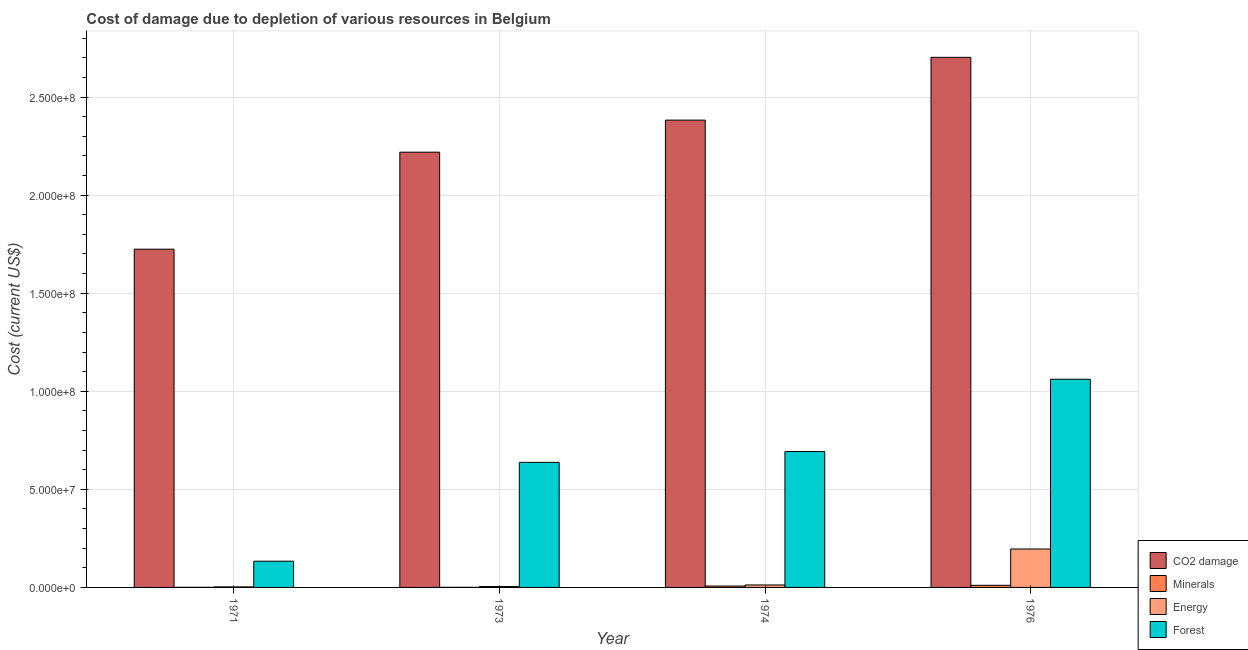How many different coloured bars are there?
Make the answer very short. 4. How many bars are there on the 4th tick from the left?
Provide a succinct answer. 4. How many bars are there on the 1st tick from the right?
Provide a short and direct response. 4. What is the label of the 4th group of bars from the left?
Your response must be concise. 1976. What is the cost of damage due to depletion of energy in 1971?
Give a very brief answer. 2.79e+05. Across all years, what is the maximum cost of damage due to depletion of energy?
Ensure brevity in your answer.  1.96e+07. Across all years, what is the minimum cost of damage due to depletion of energy?
Offer a terse response. 2.79e+05. In which year was the cost of damage due to depletion of forests maximum?
Offer a very short reply. 1976. In which year was the cost of damage due to depletion of energy minimum?
Provide a succinct answer. 1971. What is the total cost of damage due to depletion of coal in the graph?
Keep it short and to the point. 9.03e+08. What is the difference between the cost of damage due to depletion of forests in 1971 and that in 1976?
Provide a succinct answer. -9.28e+07. What is the difference between the cost of damage due to depletion of energy in 1976 and the cost of damage due to depletion of forests in 1973?
Your answer should be very brief. 1.91e+07. What is the average cost of damage due to depletion of forests per year?
Provide a short and direct response. 6.31e+07. In the year 1974, what is the difference between the cost of damage due to depletion of energy and cost of damage due to depletion of coal?
Your answer should be compact. 0. What is the ratio of the cost of damage due to depletion of coal in 1971 to that in 1973?
Your answer should be very brief. 0.78. Is the cost of damage due to depletion of minerals in 1973 less than that in 1976?
Make the answer very short. Yes. Is the difference between the cost of damage due to depletion of minerals in 1973 and 1974 greater than the difference between the cost of damage due to depletion of forests in 1973 and 1974?
Keep it short and to the point. No. What is the difference between the highest and the second highest cost of damage due to depletion of energy?
Keep it short and to the point. 1.83e+07. What is the difference between the highest and the lowest cost of damage due to depletion of coal?
Give a very brief answer. 9.78e+07. In how many years, is the cost of damage due to depletion of forests greater than the average cost of damage due to depletion of forests taken over all years?
Offer a terse response. 3. What does the 2nd bar from the left in 1974 represents?
Your answer should be very brief. Minerals. What does the 2nd bar from the right in 1973 represents?
Give a very brief answer. Energy. How many bars are there?
Your answer should be very brief. 16. Are the values on the major ticks of Y-axis written in scientific E-notation?
Offer a terse response. Yes. Where does the legend appear in the graph?
Provide a succinct answer. Bottom right. How are the legend labels stacked?
Provide a short and direct response. Vertical. What is the title of the graph?
Give a very brief answer. Cost of damage due to depletion of various resources in Belgium . What is the label or title of the Y-axis?
Your response must be concise. Cost (current US$). What is the Cost (current US$) of CO2 damage in 1971?
Make the answer very short. 1.72e+08. What is the Cost (current US$) of Minerals in 1971?
Give a very brief answer. 6.47e+04. What is the Cost (current US$) of Energy in 1971?
Provide a short and direct response. 2.79e+05. What is the Cost (current US$) of Forest in 1971?
Provide a short and direct response. 1.34e+07. What is the Cost (current US$) in CO2 damage in 1973?
Ensure brevity in your answer.  2.22e+08. What is the Cost (current US$) of Minerals in 1973?
Your response must be concise. 4.70e+04. What is the Cost (current US$) of Energy in 1973?
Offer a very short reply. 4.66e+05. What is the Cost (current US$) of Forest in 1973?
Make the answer very short. 6.38e+07. What is the Cost (current US$) in CO2 damage in 1974?
Offer a very short reply. 2.38e+08. What is the Cost (current US$) in Minerals in 1974?
Provide a short and direct response. 7.12e+05. What is the Cost (current US$) of Energy in 1974?
Offer a terse response. 1.25e+06. What is the Cost (current US$) of Forest in 1974?
Make the answer very short. 6.93e+07. What is the Cost (current US$) of CO2 damage in 1976?
Your response must be concise. 2.70e+08. What is the Cost (current US$) in Minerals in 1976?
Keep it short and to the point. 1.08e+06. What is the Cost (current US$) of Energy in 1976?
Your answer should be compact. 1.96e+07. What is the Cost (current US$) of Forest in 1976?
Your response must be concise. 1.06e+08. Across all years, what is the maximum Cost (current US$) of CO2 damage?
Your answer should be compact. 2.70e+08. Across all years, what is the maximum Cost (current US$) in Minerals?
Your answer should be compact. 1.08e+06. Across all years, what is the maximum Cost (current US$) of Energy?
Offer a very short reply. 1.96e+07. Across all years, what is the maximum Cost (current US$) in Forest?
Make the answer very short. 1.06e+08. Across all years, what is the minimum Cost (current US$) in CO2 damage?
Provide a succinct answer. 1.72e+08. Across all years, what is the minimum Cost (current US$) in Minerals?
Offer a terse response. 4.70e+04. Across all years, what is the minimum Cost (current US$) in Energy?
Offer a terse response. 2.79e+05. Across all years, what is the minimum Cost (current US$) of Forest?
Ensure brevity in your answer.  1.34e+07. What is the total Cost (current US$) in CO2 damage in the graph?
Your response must be concise. 9.03e+08. What is the total Cost (current US$) of Minerals in the graph?
Your response must be concise. 1.90e+06. What is the total Cost (current US$) of Energy in the graph?
Offer a very short reply. 2.16e+07. What is the total Cost (current US$) in Forest in the graph?
Your answer should be very brief. 2.53e+08. What is the difference between the Cost (current US$) in CO2 damage in 1971 and that in 1973?
Give a very brief answer. -4.95e+07. What is the difference between the Cost (current US$) in Minerals in 1971 and that in 1973?
Your answer should be compact. 1.76e+04. What is the difference between the Cost (current US$) of Energy in 1971 and that in 1973?
Provide a succinct answer. -1.87e+05. What is the difference between the Cost (current US$) in Forest in 1971 and that in 1973?
Offer a very short reply. -5.04e+07. What is the difference between the Cost (current US$) in CO2 damage in 1971 and that in 1974?
Make the answer very short. -6.58e+07. What is the difference between the Cost (current US$) in Minerals in 1971 and that in 1974?
Provide a succinct answer. -6.47e+05. What is the difference between the Cost (current US$) in Energy in 1971 and that in 1974?
Offer a terse response. -9.75e+05. What is the difference between the Cost (current US$) in Forest in 1971 and that in 1974?
Your answer should be very brief. -5.59e+07. What is the difference between the Cost (current US$) of CO2 damage in 1971 and that in 1976?
Provide a short and direct response. -9.78e+07. What is the difference between the Cost (current US$) in Minerals in 1971 and that in 1976?
Offer a very short reply. -1.01e+06. What is the difference between the Cost (current US$) in Energy in 1971 and that in 1976?
Offer a very short reply. -1.93e+07. What is the difference between the Cost (current US$) in Forest in 1971 and that in 1976?
Ensure brevity in your answer.  -9.28e+07. What is the difference between the Cost (current US$) of CO2 damage in 1973 and that in 1974?
Your answer should be compact. -1.63e+07. What is the difference between the Cost (current US$) of Minerals in 1973 and that in 1974?
Your answer should be very brief. -6.65e+05. What is the difference between the Cost (current US$) in Energy in 1973 and that in 1974?
Give a very brief answer. -7.87e+05. What is the difference between the Cost (current US$) in Forest in 1973 and that in 1974?
Offer a very short reply. -5.53e+06. What is the difference between the Cost (current US$) in CO2 damage in 1973 and that in 1976?
Your answer should be compact. -4.84e+07. What is the difference between the Cost (current US$) in Minerals in 1973 and that in 1976?
Make the answer very short. -1.03e+06. What is the difference between the Cost (current US$) in Energy in 1973 and that in 1976?
Your response must be concise. -1.91e+07. What is the difference between the Cost (current US$) in Forest in 1973 and that in 1976?
Your answer should be very brief. -4.24e+07. What is the difference between the Cost (current US$) in CO2 damage in 1974 and that in 1976?
Make the answer very short. -3.20e+07. What is the difference between the Cost (current US$) of Minerals in 1974 and that in 1976?
Make the answer very short. -3.66e+05. What is the difference between the Cost (current US$) of Energy in 1974 and that in 1976?
Make the answer very short. -1.83e+07. What is the difference between the Cost (current US$) in Forest in 1974 and that in 1976?
Make the answer very short. -3.69e+07. What is the difference between the Cost (current US$) of CO2 damage in 1971 and the Cost (current US$) of Minerals in 1973?
Give a very brief answer. 1.72e+08. What is the difference between the Cost (current US$) in CO2 damage in 1971 and the Cost (current US$) in Energy in 1973?
Offer a terse response. 1.72e+08. What is the difference between the Cost (current US$) in CO2 damage in 1971 and the Cost (current US$) in Forest in 1973?
Your answer should be very brief. 1.09e+08. What is the difference between the Cost (current US$) of Minerals in 1971 and the Cost (current US$) of Energy in 1973?
Ensure brevity in your answer.  -4.01e+05. What is the difference between the Cost (current US$) in Minerals in 1971 and the Cost (current US$) in Forest in 1973?
Your response must be concise. -6.37e+07. What is the difference between the Cost (current US$) of Energy in 1971 and the Cost (current US$) of Forest in 1973?
Give a very brief answer. -6.35e+07. What is the difference between the Cost (current US$) in CO2 damage in 1971 and the Cost (current US$) in Minerals in 1974?
Offer a terse response. 1.72e+08. What is the difference between the Cost (current US$) of CO2 damage in 1971 and the Cost (current US$) of Energy in 1974?
Your response must be concise. 1.71e+08. What is the difference between the Cost (current US$) of CO2 damage in 1971 and the Cost (current US$) of Forest in 1974?
Provide a short and direct response. 1.03e+08. What is the difference between the Cost (current US$) in Minerals in 1971 and the Cost (current US$) in Energy in 1974?
Give a very brief answer. -1.19e+06. What is the difference between the Cost (current US$) in Minerals in 1971 and the Cost (current US$) in Forest in 1974?
Make the answer very short. -6.92e+07. What is the difference between the Cost (current US$) of Energy in 1971 and the Cost (current US$) of Forest in 1974?
Give a very brief answer. -6.90e+07. What is the difference between the Cost (current US$) of CO2 damage in 1971 and the Cost (current US$) of Minerals in 1976?
Your answer should be very brief. 1.71e+08. What is the difference between the Cost (current US$) in CO2 damage in 1971 and the Cost (current US$) in Energy in 1976?
Your answer should be very brief. 1.53e+08. What is the difference between the Cost (current US$) in CO2 damage in 1971 and the Cost (current US$) in Forest in 1976?
Ensure brevity in your answer.  6.63e+07. What is the difference between the Cost (current US$) of Minerals in 1971 and the Cost (current US$) of Energy in 1976?
Give a very brief answer. -1.95e+07. What is the difference between the Cost (current US$) of Minerals in 1971 and the Cost (current US$) of Forest in 1976?
Provide a succinct answer. -1.06e+08. What is the difference between the Cost (current US$) of Energy in 1971 and the Cost (current US$) of Forest in 1976?
Make the answer very short. -1.06e+08. What is the difference between the Cost (current US$) of CO2 damage in 1973 and the Cost (current US$) of Minerals in 1974?
Offer a very short reply. 2.21e+08. What is the difference between the Cost (current US$) of CO2 damage in 1973 and the Cost (current US$) of Energy in 1974?
Ensure brevity in your answer.  2.21e+08. What is the difference between the Cost (current US$) in CO2 damage in 1973 and the Cost (current US$) in Forest in 1974?
Offer a very short reply. 1.53e+08. What is the difference between the Cost (current US$) of Minerals in 1973 and the Cost (current US$) of Energy in 1974?
Make the answer very short. -1.21e+06. What is the difference between the Cost (current US$) in Minerals in 1973 and the Cost (current US$) in Forest in 1974?
Provide a short and direct response. -6.92e+07. What is the difference between the Cost (current US$) of Energy in 1973 and the Cost (current US$) of Forest in 1974?
Make the answer very short. -6.88e+07. What is the difference between the Cost (current US$) of CO2 damage in 1973 and the Cost (current US$) of Minerals in 1976?
Provide a short and direct response. 2.21e+08. What is the difference between the Cost (current US$) of CO2 damage in 1973 and the Cost (current US$) of Energy in 1976?
Make the answer very short. 2.02e+08. What is the difference between the Cost (current US$) of CO2 damage in 1973 and the Cost (current US$) of Forest in 1976?
Ensure brevity in your answer.  1.16e+08. What is the difference between the Cost (current US$) in Minerals in 1973 and the Cost (current US$) in Energy in 1976?
Provide a succinct answer. -1.95e+07. What is the difference between the Cost (current US$) in Minerals in 1973 and the Cost (current US$) in Forest in 1976?
Your response must be concise. -1.06e+08. What is the difference between the Cost (current US$) in Energy in 1973 and the Cost (current US$) in Forest in 1976?
Offer a very short reply. -1.06e+08. What is the difference between the Cost (current US$) of CO2 damage in 1974 and the Cost (current US$) of Minerals in 1976?
Offer a terse response. 2.37e+08. What is the difference between the Cost (current US$) of CO2 damage in 1974 and the Cost (current US$) of Energy in 1976?
Your answer should be very brief. 2.19e+08. What is the difference between the Cost (current US$) of CO2 damage in 1974 and the Cost (current US$) of Forest in 1976?
Your response must be concise. 1.32e+08. What is the difference between the Cost (current US$) in Minerals in 1974 and the Cost (current US$) in Energy in 1976?
Ensure brevity in your answer.  -1.89e+07. What is the difference between the Cost (current US$) of Minerals in 1974 and the Cost (current US$) of Forest in 1976?
Give a very brief answer. -1.05e+08. What is the difference between the Cost (current US$) in Energy in 1974 and the Cost (current US$) in Forest in 1976?
Provide a succinct answer. -1.05e+08. What is the average Cost (current US$) in CO2 damage per year?
Your answer should be compact. 2.26e+08. What is the average Cost (current US$) of Minerals per year?
Provide a short and direct response. 4.75e+05. What is the average Cost (current US$) of Energy per year?
Provide a succinct answer. 5.40e+06. What is the average Cost (current US$) of Forest per year?
Ensure brevity in your answer.  6.31e+07. In the year 1971, what is the difference between the Cost (current US$) in CO2 damage and Cost (current US$) in Minerals?
Offer a terse response. 1.72e+08. In the year 1971, what is the difference between the Cost (current US$) of CO2 damage and Cost (current US$) of Energy?
Offer a very short reply. 1.72e+08. In the year 1971, what is the difference between the Cost (current US$) of CO2 damage and Cost (current US$) of Forest?
Offer a terse response. 1.59e+08. In the year 1971, what is the difference between the Cost (current US$) of Minerals and Cost (current US$) of Energy?
Your answer should be compact. -2.14e+05. In the year 1971, what is the difference between the Cost (current US$) of Minerals and Cost (current US$) of Forest?
Keep it short and to the point. -1.33e+07. In the year 1971, what is the difference between the Cost (current US$) in Energy and Cost (current US$) in Forest?
Make the answer very short. -1.31e+07. In the year 1973, what is the difference between the Cost (current US$) in CO2 damage and Cost (current US$) in Minerals?
Your response must be concise. 2.22e+08. In the year 1973, what is the difference between the Cost (current US$) of CO2 damage and Cost (current US$) of Energy?
Make the answer very short. 2.21e+08. In the year 1973, what is the difference between the Cost (current US$) of CO2 damage and Cost (current US$) of Forest?
Ensure brevity in your answer.  1.58e+08. In the year 1973, what is the difference between the Cost (current US$) of Minerals and Cost (current US$) of Energy?
Keep it short and to the point. -4.19e+05. In the year 1973, what is the difference between the Cost (current US$) of Minerals and Cost (current US$) of Forest?
Your response must be concise. -6.37e+07. In the year 1973, what is the difference between the Cost (current US$) of Energy and Cost (current US$) of Forest?
Your response must be concise. -6.33e+07. In the year 1974, what is the difference between the Cost (current US$) of CO2 damage and Cost (current US$) of Minerals?
Make the answer very short. 2.38e+08. In the year 1974, what is the difference between the Cost (current US$) of CO2 damage and Cost (current US$) of Energy?
Keep it short and to the point. 2.37e+08. In the year 1974, what is the difference between the Cost (current US$) in CO2 damage and Cost (current US$) in Forest?
Ensure brevity in your answer.  1.69e+08. In the year 1974, what is the difference between the Cost (current US$) in Minerals and Cost (current US$) in Energy?
Give a very brief answer. -5.41e+05. In the year 1974, what is the difference between the Cost (current US$) of Minerals and Cost (current US$) of Forest?
Ensure brevity in your answer.  -6.86e+07. In the year 1974, what is the difference between the Cost (current US$) of Energy and Cost (current US$) of Forest?
Your answer should be very brief. -6.80e+07. In the year 1976, what is the difference between the Cost (current US$) of CO2 damage and Cost (current US$) of Minerals?
Your answer should be very brief. 2.69e+08. In the year 1976, what is the difference between the Cost (current US$) in CO2 damage and Cost (current US$) in Energy?
Ensure brevity in your answer.  2.51e+08. In the year 1976, what is the difference between the Cost (current US$) in CO2 damage and Cost (current US$) in Forest?
Your answer should be compact. 1.64e+08. In the year 1976, what is the difference between the Cost (current US$) in Minerals and Cost (current US$) in Energy?
Provide a short and direct response. -1.85e+07. In the year 1976, what is the difference between the Cost (current US$) of Minerals and Cost (current US$) of Forest?
Keep it short and to the point. -1.05e+08. In the year 1976, what is the difference between the Cost (current US$) in Energy and Cost (current US$) in Forest?
Make the answer very short. -8.66e+07. What is the ratio of the Cost (current US$) of CO2 damage in 1971 to that in 1973?
Your response must be concise. 0.78. What is the ratio of the Cost (current US$) of Minerals in 1971 to that in 1973?
Your response must be concise. 1.38. What is the ratio of the Cost (current US$) in Energy in 1971 to that in 1973?
Provide a short and direct response. 0.6. What is the ratio of the Cost (current US$) of Forest in 1971 to that in 1973?
Offer a terse response. 0.21. What is the ratio of the Cost (current US$) of CO2 damage in 1971 to that in 1974?
Offer a terse response. 0.72. What is the ratio of the Cost (current US$) in Minerals in 1971 to that in 1974?
Offer a terse response. 0.09. What is the ratio of the Cost (current US$) in Energy in 1971 to that in 1974?
Provide a short and direct response. 0.22. What is the ratio of the Cost (current US$) in Forest in 1971 to that in 1974?
Make the answer very short. 0.19. What is the ratio of the Cost (current US$) of CO2 damage in 1971 to that in 1976?
Offer a terse response. 0.64. What is the ratio of the Cost (current US$) of Minerals in 1971 to that in 1976?
Ensure brevity in your answer.  0.06. What is the ratio of the Cost (current US$) in Energy in 1971 to that in 1976?
Offer a very short reply. 0.01. What is the ratio of the Cost (current US$) in Forest in 1971 to that in 1976?
Make the answer very short. 0.13. What is the ratio of the Cost (current US$) of CO2 damage in 1973 to that in 1974?
Provide a short and direct response. 0.93. What is the ratio of the Cost (current US$) in Minerals in 1973 to that in 1974?
Ensure brevity in your answer.  0.07. What is the ratio of the Cost (current US$) in Energy in 1973 to that in 1974?
Offer a very short reply. 0.37. What is the ratio of the Cost (current US$) of Forest in 1973 to that in 1974?
Make the answer very short. 0.92. What is the ratio of the Cost (current US$) in CO2 damage in 1973 to that in 1976?
Provide a short and direct response. 0.82. What is the ratio of the Cost (current US$) of Minerals in 1973 to that in 1976?
Give a very brief answer. 0.04. What is the ratio of the Cost (current US$) of Energy in 1973 to that in 1976?
Your response must be concise. 0.02. What is the ratio of the Cost (current US$) in Forest in 1973 to that in 1976?
Your answer should be very brief. 0.6. What is the ratio of the Cost (current US$) in CO2 damage in 1974 to that in 1976?
Keep it short and to the point. 0.88. What is the ratio of the Cost (current US$) of Minerals in 1974 to that in 1976?
Your response must be concise. 0.66. What is the ratio of the Cost (current US$) of Energy in 1974 to that in 1976?
Your response must be concise. 0.06. What is the ratio of the Cost (current US$) of Forest in 1974 to that in 1976?
Your answer should be very brief. 0.65. What is the difference between the highest and the second highest Cost (current US$) of CO2 damage?
Your response must be concise. 3.20e+07. What is the difference between the highest and the second highest Cost (current US$) of Minerals?
Offer a very short reply. 3.66e+05. What is the difference between the highest and the second highest Cost (current US$) in Energy?
Your answer should be very brief. 1.83e+07. What is the difference between the highest and the second highest Cost (current US$) in Forest?
Provide a succinct answer. 3.69e+07. What is the difference between the highest and the lowest Cost (current US$) of CO2 damage?
Give a very brief answer. 9.78e+07. What is the difference between the highest and the lowest Cost (current US$) of Minerals?
Ensure brevity in your answer.  1.03e+06. What is the difference between the highest and the lowest Cost (current US$) of Energy?
Provide a succinct answer. 1.93e+07. What is the difference between the highest and the lowest Cost (current US$) of Forest?
Offer a terse response. 9.28e+07. 